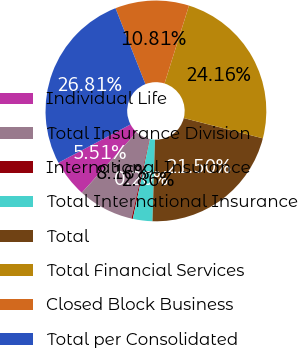Convert chart. <chart><loc_0><loc_0><loc_500><loc_500><pie_chart><fcel>Individual Life<fcel>Total Insurance Division<fcel>International Insurance<fcel>Total International Insurance<fcel>Total<fcel>Total Financial Services<fcel>Closed Block Business<fcel>Total per Consolidated<nl><fcel>5.51%<fcel>8.16%<fcel>0.2%<fcel>2.86%<fcel>21.5%<fcel>24.16%<fcel>10.81%<fcel>26.81%<nl></chart> 